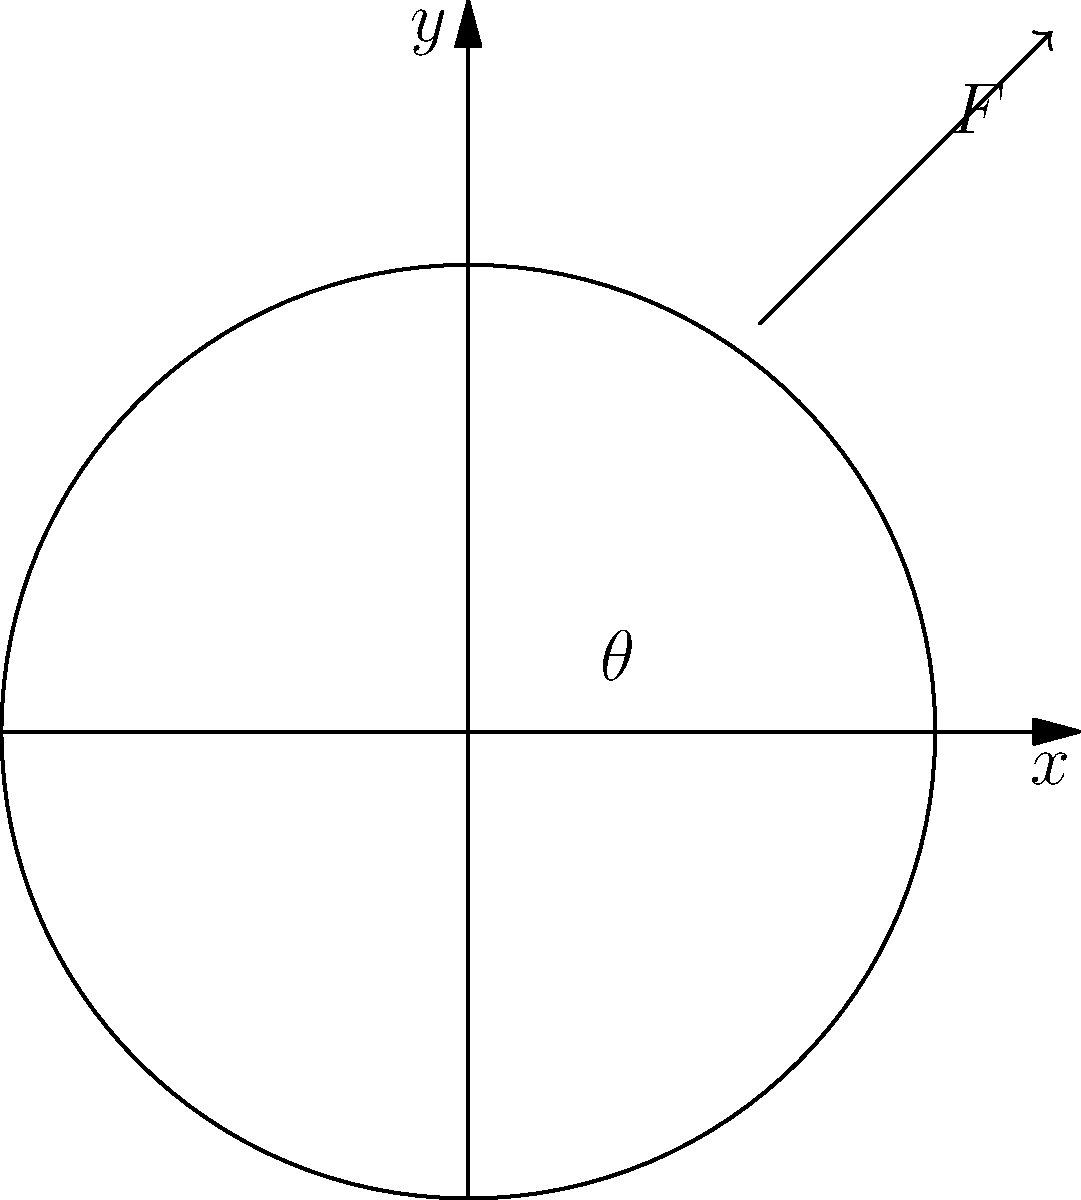A blunt trauma injury is observed on a victim's skull. The impact point is located at coordinates (0.5, 0.7) on a unit circle representation of the skull. The applied force vector makes an angle $\theta$ with the positive x-axis. Given that the magnitude of the force is 1000 N, determine the x and y components of the force vector. To solve this problem, we'll follow these steps:

1) First, we need to determine the angle $\theta$. We can do this using the arctangent function:
   $\theta = \arctan(\frac{y}{x}) = \arctan(\frac{0.7}{0.5}) \approx 54.46°$

2) Now that we have the angle, we can use trigonometric functions to find the x and y components of the force:

   $F_x = F \cos(\theta)$
   $F_y = F \sin(\theta)$

3) Given that the magnitude of the force $F = 1000$ N, we can calculate:

   $F_x = 1000 \cos(54.46°) \approx 579.23$ N
   $F_y = 1000 \sin(54.46°) \approx 815.04$ N

4) These values represent the components of the force in the positive x and y directions. In the context of blunt trauma analysis, this information can help determine the direction and magnitude of the impact, which is crucial for reconstructing the events leading to the injury.
Answer: $F_x \approx 579.23$ N, $F_y \approx 815.04$ N 